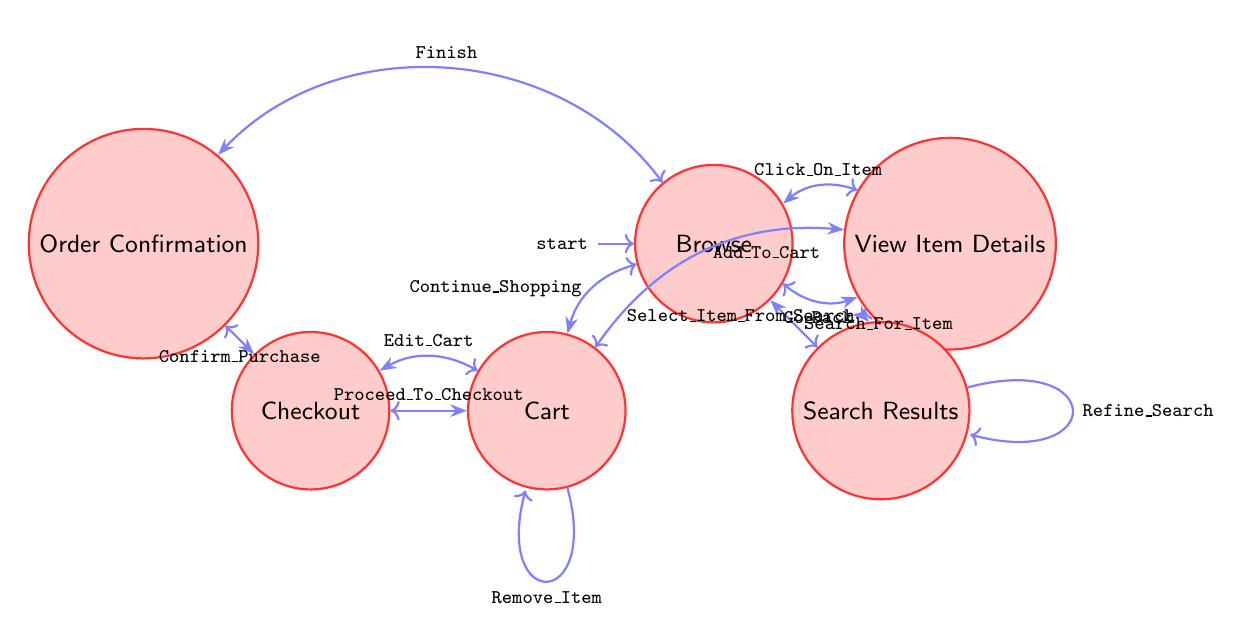What's the starting state of the diagram? The diagram indicates that the initial or starting state is 'Browse', as it is marked as the initial node.
Answer: Browse How many states are in the diagram? By counting the nodes labeled in the diagram, there are a total of six distinct states: Browse, View Item Details, Search Results, Cart, Checkout, and Order Confirmation.
Answer: 6 What event leads from 'Cart' to 'Checkout'? The event that transitions from 'Cart' to 'Checkout' is labeled 'Proceed_To_Checkout', which indicates the user's action to proceed with the purchase.
Answer: Proceed_To_Checkout Which state can be reached by clicking on an item while in 'Browse'? Clicking on an item in the 'Browse' state leads to the 'View_Item_Details' state, according to the transition indicated.
Answer: View Item Details What happens if the user confirms their purchase in 'Checkout'? Upon confirming the purchase in the 'Checkout' state, the user transitions to the 'Order_Confirmation' state, indicating that the purchase has been completed.
Answer: Order Confirmation What is a possible action to return to 'Browse' from 'View_Item_Details'? In the 'View_Item_Details' state, the action 'Go_Back' allows the user to return to the 'Browse' state, facilitating navigation through the store.
Answer: Go_Back What can be done in the 'Search_Results' state? In the 'Search_Results' state, the user can either select an item from the search results or refine the search to narrow down the displayed items, as indicated by the transitions available.
Answer: Select_Item_From_Search, Refine_Search What is the relationship between 'Order_Confirmation' and 'Browse'? The relationship is one-way, transitioned by the event 'Finish', which signifies that after receiving an order confirmation, the user can return to 'Browse' to continue shopping.
Answer: Finish What event keeps the user in the 'Cart' state? The event that allows the user to remain in the 'Cart' state is 'Remove_Item', which indicates that the user can modify their cart without leaving this state.
Answer: Remove_Item 